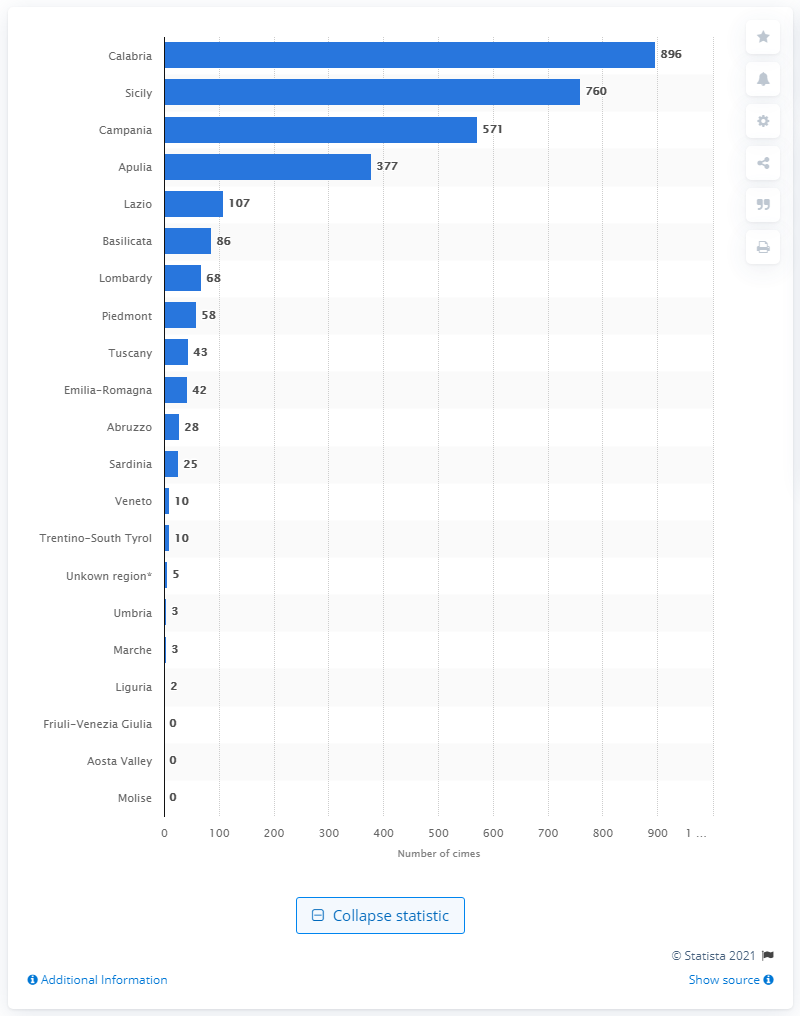Draw attention to some important aspects in this diagram. The region of Calabria had the highest number of mafia crimes in 2018, according to recent statistics. In the region of Calabria in 2018, a total of 896 criminal reports were recorded. 